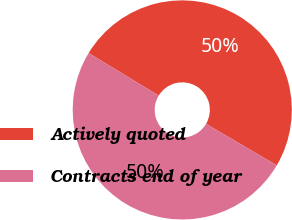Convert chart. <chart><loc_0><loc_0><loc_500><loc_500><pie_chart><fcel>Actively quoted<fcel>Contracts end of year<nl><fcel>49.75%<fcel>50.25%<nl></chart> 